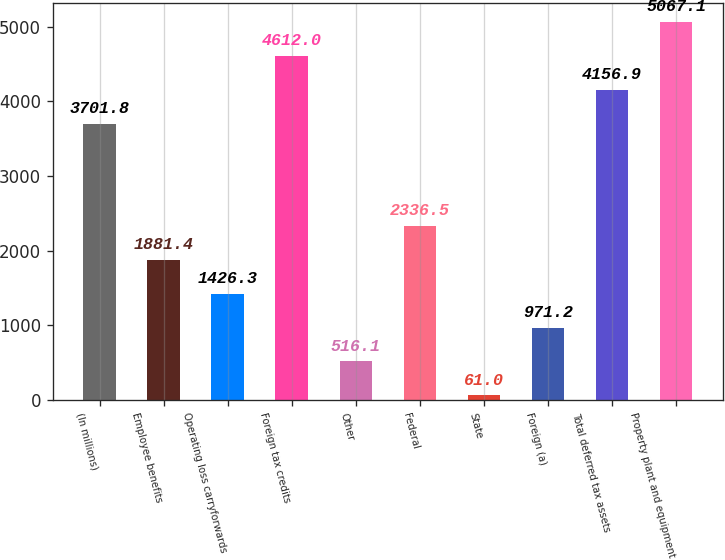Convert chart. <chart><loc_0><loc_0><loc_500><loc_500><bar_chart><fcel>(In millions)<fcel>Employee benefits<fcel>Operating loss carryforwards<fcel>Foreign tax credits<fcel>Other<fcel>Federal<fcel>State<fcel>Foreign (a)<fcel>Total deferred tax assets<fcel>Property plant and equipment<nl><fcel>3701.8<fcel>1881.4<fcel>1426.3<fcel>4612<fcel>516.1<fcel>2336.5<fcel>61<fcel>971.2<fcel>4156.9<fcel>5067.1<nl></chart> 